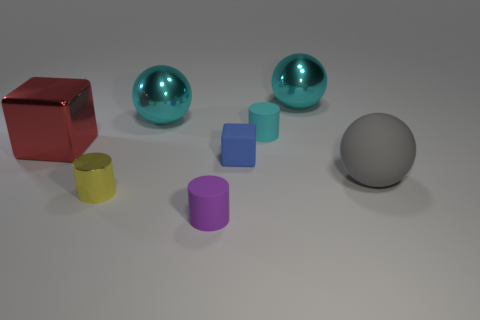What is the material of the purple thing that is the same size as the blue rubber thing?
Provide a succinct answer. Rubber. There is a red metal block to the left of the big cyan shiny sphere that is left of the tiny cyan object; how big is it?
Your response must be concise. Large. There is a block that is in front of the red metallic object; is its size the same as the purple matte cylinder?
Provide a short and direct response. Yes. Is the number of small purple matte objects that are on the left side of the purple cylinder greater than the number of large things that are in front of the small yellow metallic cylinder?
Make the answer very short. No. What is the shape of the big thing that is both to the left of the purple object and behind the red block?
Give a very brief answer. Sphere. What shape is the tiny object behind the red metallic object?
Keep it short and to the point. Cylinder. There is a ball that is to the left of the matte cylinder that is in front of the matte cylinder behind the gray matte sphere; how big is it?
Your response must be concise. Large. Is the small metallic object the same shape as the tiny cyan object?
Offer a very short reply. Yes. What is the size of the cylinder that is to the left of the blue matte block and behind the tiny purple cylinder?
Provide a succinct answer. Small. What is the material of the small cyan object that is the same shape as the purple rubber thing?
Provide a succinct answer. Rubber. 